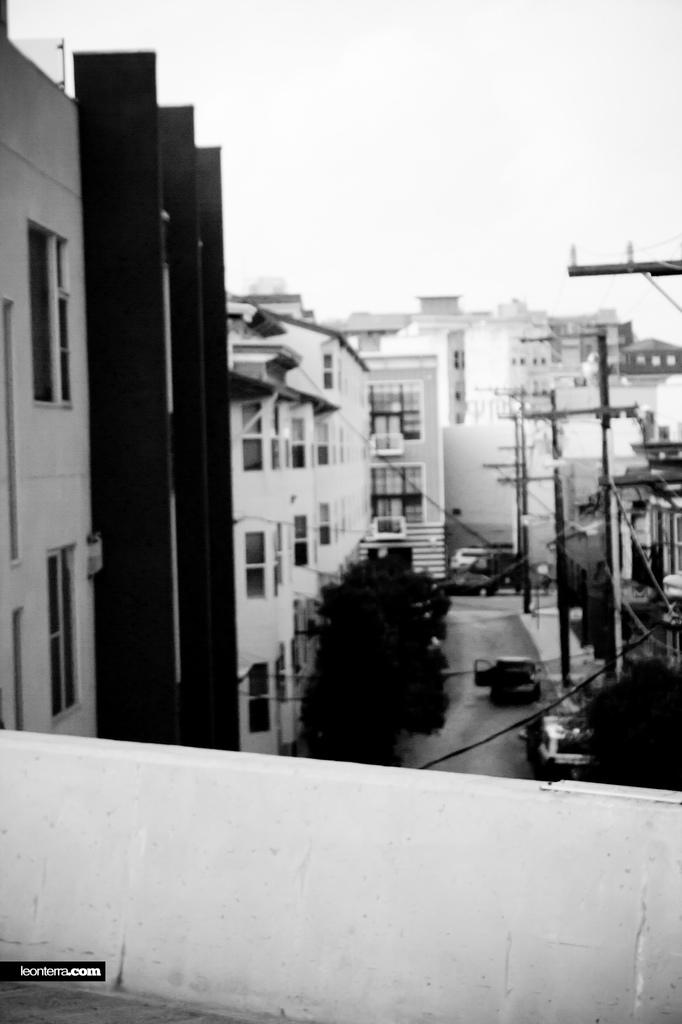What is located at the front of the image? There is a balcony in the front of the image. What can be seen in the background of the image? There are buildings, poles, trees, and cars in the background of the image. What is the condition of the sky in the image? The sky is cloudy in the image. Can you see a woman writing in a notebook and laughing in the image? There is no woman, notebook, or laughter present in the image. 